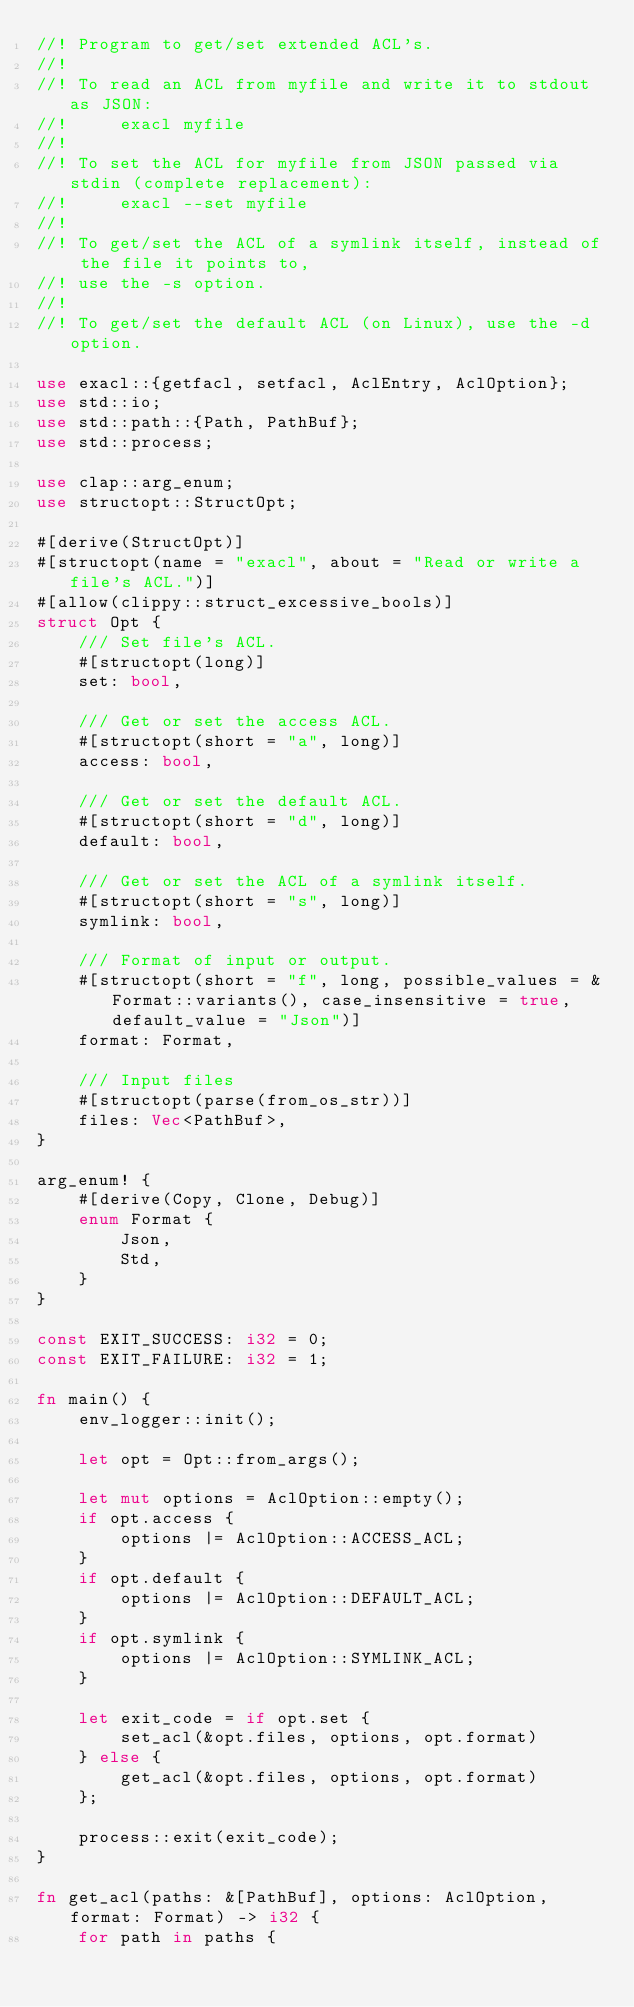<code> <loc_0><loc_0><loc_500><loc_500><_Rust_>//! Program to get/set extended ACL's.
//!
//! To read an ACL from myfile and write it to stdout as JSON:
//!     exacl myfile
//!
//! To set the ACL for myfile from JSON passed via stdin (complete replacement):
//!     exacl --set myfile
//!
//! To get/set the ACL of a symlink itself, instead of the file it points to,
//! use the -s option.
//!
//! To get/set the default ACL (on Linux), use the -d option.

use exacl::{getfacl, setfacl, AclEntry, AclOption};
use std::io;
use std::path::{Path, PathBuf};
use std::process;

use clap::arg_enum;
use structopt::StructOpt;

#[derive(StructOpt)]
#[structopt(name = "exacl", about = "Read or write a file's ACL.")]
#[allow(clippy::struct_excessive_bools)]
struct Opt {
    /// Set file's ACL.
    #[structopt(long)]
    set: bool,

    /// Get or set the access ACL.
    #[structopt(short = "a", long)]
    access: bool,

    /// Get or set the default ACL.
    #[structopt(short = "d", long)]
    default: bool,

    /// Get or set the ACL of a symlink itself.
    #[structopt(short = "s", long)]
    symlink: bool,

    /// Format of input or output.
    #[structopt(short = "f", long, possible_values = &Format::variants(), case_insensitive = true, default_value = "Json")]
    format: Format,

    /// Input files
    #[structopt(parse(from_os_str))]
    files: Vec<PathBuf>,
}

arg_enum! {
    #[derive(Copy, Clone, Debug)]
    enum Format {
        Json,
        Std,
    }
}

const EXIT_SUCCESS: i32 = 0;
const EXIT_FAILURE: i32 = 1;

fn main() {
    env_logger::init();

    let opt = Opt::from_args();

    let mut options = AclOption::empty();
    if opt.access {
        options |= AclOption::ACCESS_ACL;
    }
    if opt.default {
        options |= AclOption::DEFAULT_ACL;
    }
    if opt.symlink {
        options |= AclOption::SYMLINK_ACL;
    }

    let exit_code = if opt.set {
        set_acl(&opt.files, options, opt.format)
    } else {
        get_acl(&opt.files, options, opt.format)
    };

    process::exit(exit_code);
}

fn get_acl(paths: &[PathBuf], options: AclOption, format: Format) -> i32 {
    for path in paths {</code> 